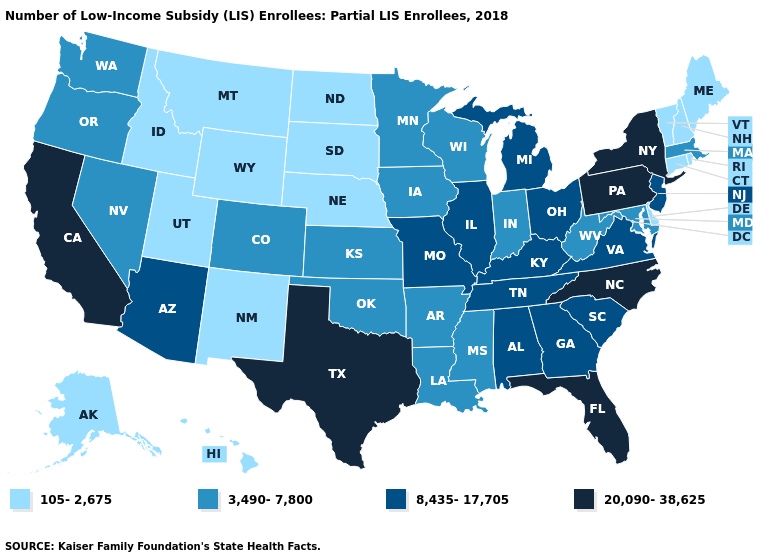Name the states that have a value in the range 3,490-7,800?
Give a very brief answer. Arkansas, Colorado, Indiana, Iowa, Kansas, Louisiana, Maryland, Massachusetts, Minnesota, Mississippi, Nevada, Oklahoma, Oregon, Washington, West Virginia, Wisconsin. Is the legend a continuous bar?
Concise answer only. No. Name the states that have a value in the range 8,435-17,705?
Short answer required. Alabama, Arizona, Georgia, Illinois, Kentucky, Michigan, Missouri, New Jersey, Ohio, South Carolina, Tennessee, Virginia. How many symbols are there in the legend?
Keep it brief. 4. How many symbols are there in the legend?
Short answer required. 4. Does New York have the same value as Oklahoma?
Quick response, please. No. What is the highest value in the West ?
Answer briefly. 20,090-38,625. Which states have the lowest value in the West?
Concise answer only. Alaska, Hawaii, Idaho, Montana, New Mexico, Utah, Wyoming. Does the first symbol in the legend represent the smallest category?
Answer briefly. Yes. Does New York have the same value as North Carolina?
Answer briefly. Yes. Which states have the highest value in the USA?
Answer briefly. California, Florida, New York, North Carolina, Pennsylvania, Texas. What is the value of Connecticut?
Give a very brief answer. 105-2,675. Name the states that have a value in the range 20,090-38,625?
Short answer required. California, Florida, New York, North Carolina, Pennsylvania, Texas. How many symbols are there in the legend?
Answer briefly. 4. What is the value of Ohio?
Concise answer only. 8,435-17,705. 